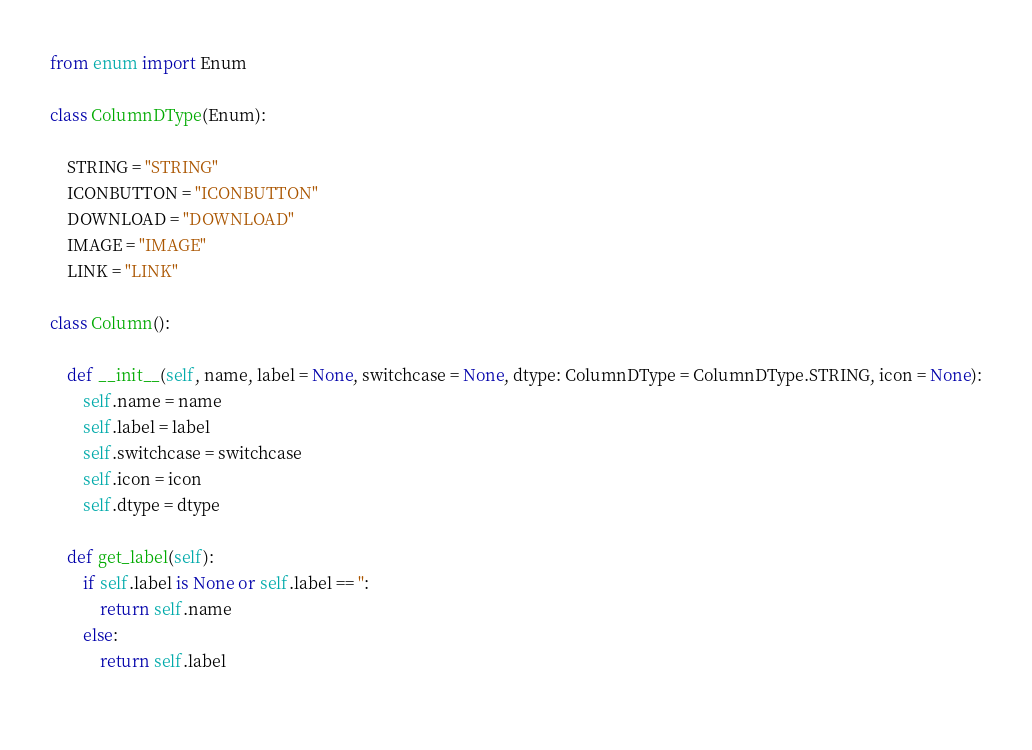<code> <loc_0><loc_0><loc_500><loc_500><_Python_>from enum import Enum

class ColumnDType(Enum):
    
    STRING = "STRING"
    ICONBUTTON = "ICONBUTTON"
    DOWNLOAD = "DOWNLOAD"
    IMAGE = "IMAGE"
    LINK = "LINK"

class Column():
    
    def __init__(self, name, label = None, switchcase = None, dtype: ColumnDType = ColumnDType.STRING, icon = None):
        self.name = name
        self.label = label
        self.switchcase = switchcase
        self.icon = icon
        self.dtype = dtype
        
    def get_label(self):
        if self.label is None or self.label == '':
            return self.name
        else:
            return self.label
        </code> 